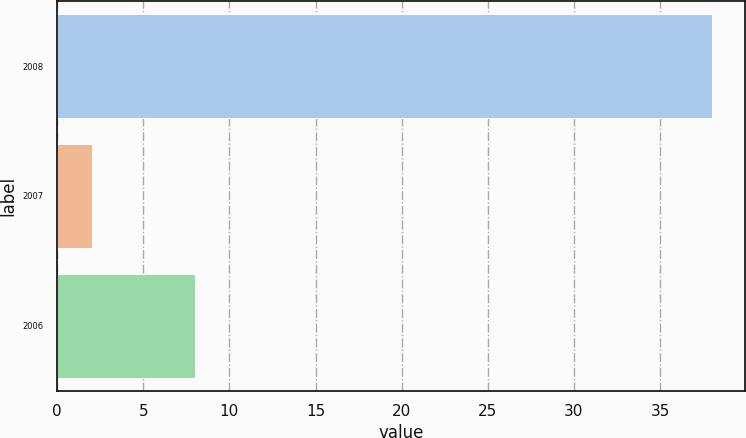<chart> <loc_0><loc_0><loc_500><loc_500><bar_chart><fcel>2008<fcel>2007<fcel>2006<nl><fcel>38<fcel>2<fcel>8<nl></chart> 